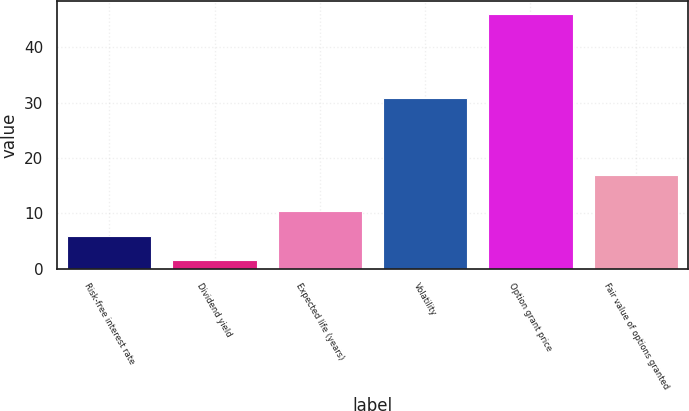Convert chart. <chart><loc_0><loc_0><loc_500><loc_500><bar_chart><fcel>Risk-free interest rate<fcel>Dividend yield<fcel>Expected life (years)<fcel>Volatility<fcel>Option grant price<fcel>Fair value of options granted<nl><fcel>5.97<fcel>1.52<fcel>10.42<fcel>30.73<fcel>46<fcel>17.01<nl></chart> 